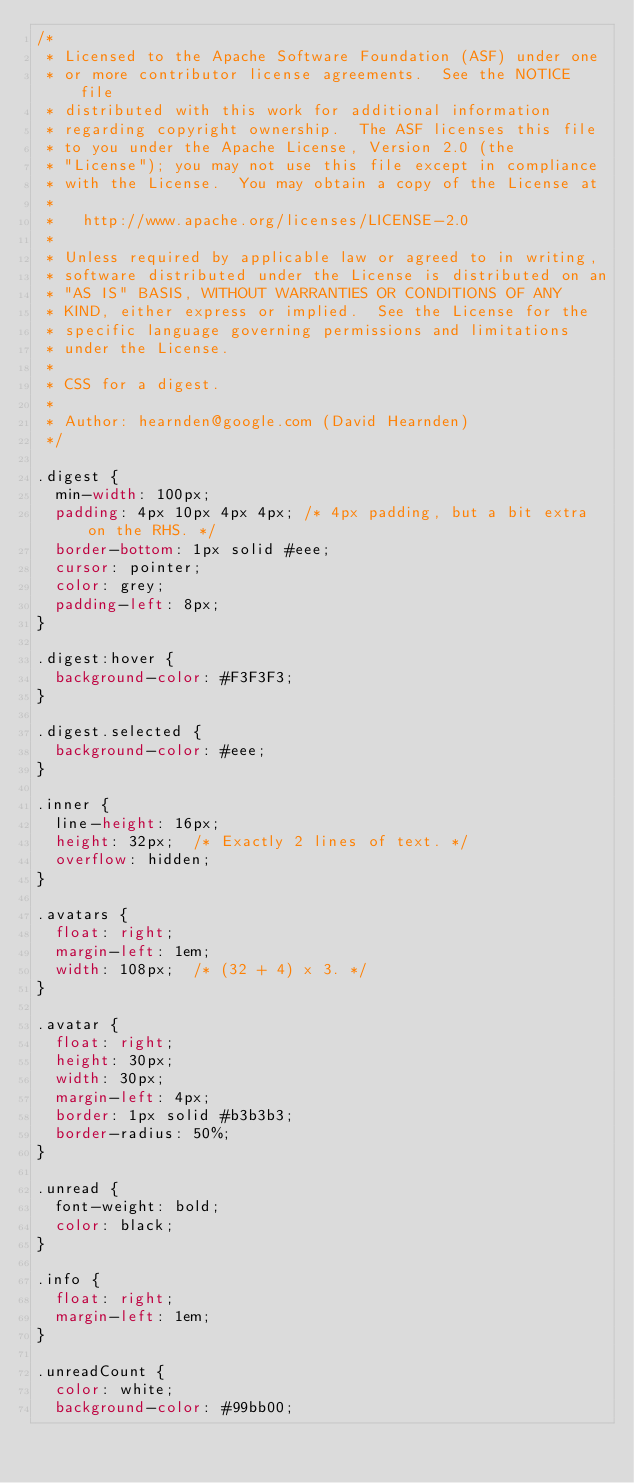<code> <loc_0><loc_0><loc_500><loc_500><_CSS_>/*
 * Licensed to the Apache Software Foundation (ASF) under one
 * or more contributor license agreements.  See the NOTICE file
 * distributed with this work for additional information
 * regarding copyright ownership.  The ASF licenses this file
 * to you under the Apache License, Version 2.0 (the
 * "License"); you may not use this file except in compliance
 * with the License.  You may obtain a copy of the License at
 *
 *   http://www.apache.org/licenses/LICENSE-2.0
 *
 * Unless required by applicable law or agreed to in writing,
 * software distributed under the License is distributed on an
 * "AS IS" BASIS, WITHOUT WARRANTIES OR CONDITIONS OF ANY
 * KIND, either express or implied.  See the License for the
 * specific language governing permissions and limitations
 * under the License.
 *
 * CSS for a digest.
 *
 * Author: hearnden@google.com (David Hearnden)
 */

.digest {
  min-width: 100px;
  padding: 4px 10px 4px 4px; /* 4px padding, but a bit extra on the RHS. */
  border-bottom: 1px solid #eee;
  cursor: pointer;
  color: grey;
  padding-left: 8px;
}

.digest:hover {
  background-color: #F3F3F3;
}

.digest.selected {
  background-color: #eee;
}

.inner {
  line-height: 16px;
  height: 32px;  /* Exactly 2 lines of text. */
  overflow: hidden;
}

.avatars {
  float: right;
  margin-left: 1em;
  width: 108px;  /* (32 + 4) x 3. */
}

.avatar {
  float: right;
  height: 30px;
  width: 30px;
  margin-left: 4px;
  border: 1px solid #b3b3b3;
  border-radius: 50%;
}

.unread {
  font-weight: bold;
  color: black;
}

.info {
  float: right;
  margin-left: 1em;
}

.unreadCount {
  color: white;
  background-color: #99bb00;
</code> 